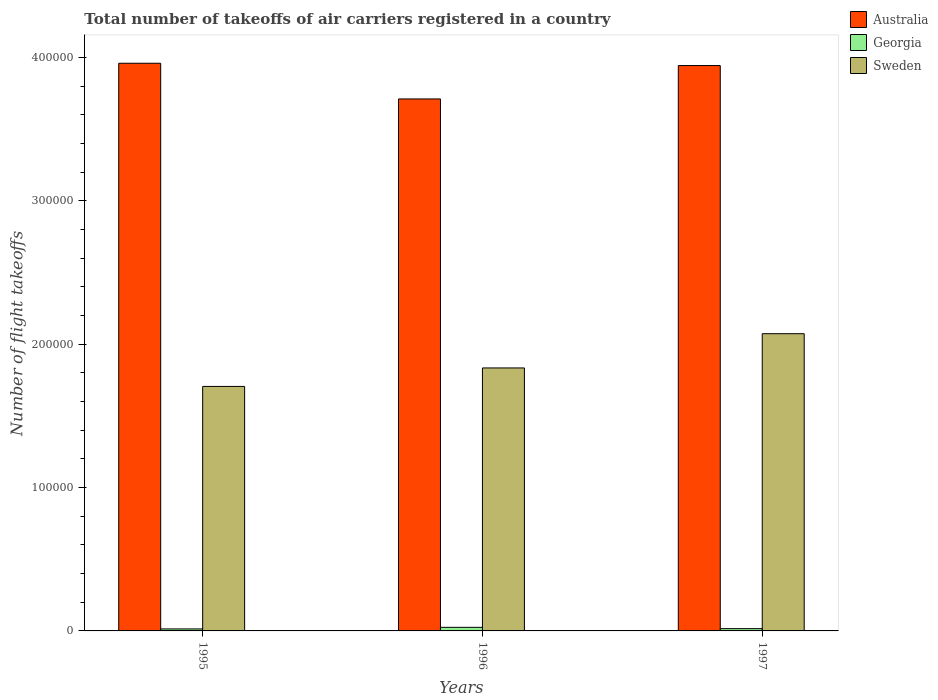How many different coloured bars are there?
Offer a terse response. 3. How many groups of bars are there?
Keep it short and to the point. 3. Are the number of bars per tick equal to the number of legend labels?
Provide a short and direct response. Yes. In how many cases, is the number of bars for a given year not equal to the number of legend labels?
Keep it short and to the point. 0. What is the total number of flight takeoffs in Sweden in 1997?
Provide a succinct answer. 2.07e+05. Across all years, what is the maximum total number of flight takeoffs in Australia?
Offer a very short reply. 3.96e+05. Across all years, what is the minimum total number of flight takeoffs in Australia?
Provide a succinct answer. 3.71e+05. In which year was the total number of flight takeoffs in Georgia maximum?
Offer a very short reply. 1996. In which year was the total number of flight takeoffs in Georgia minimum?
Make the answer very short. 1995. What is the total total number of flight takeoffs in Georgia in the graph?
Provide a short and direct response. 5500. What is the difference between the total number of flight takeoffs in Australia in 1995 and that in 1997?
Your response must be concise. 1600. What is the difference between the total number of flight takeoffs in Australia in 1996 and the total number of flight takeoffs in Sweden in 1995?
Provide a succinct answer. 2.01e+05. What is the average total number of flight takeoffs in Sweden per year?
Your answer should be compact. 1.87e+05. In the year 1997, what is the difference between the total number of flight takeoffs in Sweden and total number of flight takeoffs in Georgia?
Ensure brevity in your answer.  2.06e+05. What is the ratio of the total number of flight takeoffs in Georgia in 1995 to that in 1996?
Give a very brief answer. 0.56. What is the difference between the highest and the second highest total number of flight takeoffs in Sweden?
Provide a short and direct response. 2.39e+04. What is the difference between the highest and the lowest total number of flight takeoffs in Sweden?
Offer a terse response. 3.68e+04. Is the sum of the total number of flight takeoffs in Sweden in 1995 and 1996 greater than the maximum total number of flight takeoffs in Australia across all years?
Make the answer very short. No. What does the 2nd bar from the left in 1996 represents?
Ensure brevity in your answer.  Georgia. What does the 3rd bar from the right in 1996 represents?
Provide a succinct answer. Australia. Are all the bars in the graph horizontal?
Provide a short and direct response. No. How many years are there in the graph?
Offer a very short reply. 3. Are the values on the major ticks of Y-axis written in scientific E-notation?
Your response must be concise. No. Does the graph contain any zero values?
Ensure brevity in your answer.  No. Does the graph contain grids?
Give a very brief answer. No. Where does the legend appear in the graph?
Make the answer very short. Top right. What is the title of the graph?
Your answer should be very brief. Total number of takeoffs of air carriers registered in a country. Does "Kenya" appear as one of the legend labels in the graph?
Offer a terse response. No. What is the label or title of the X-axis?
Your answer should be very brief. Years. What is the label or title of the Y-axis?
Ensure brevity in your answer.  Number of flight takeoffs. What is the Number of flight takeoffs of Australia in 1995?
Keep it short and to the point. 3.96e+05. What is the Number of flight takeoffs of Georgia in 1995?
Keep it short and to the point. 1400. What is the Number of flight takeoffs of Sweden in 1995?
Offer a very short reply. 1.71e+05. What is the Number of flight takeoffs in Australia in 1996?
Give a very brief answer. 3.71e+05. What is the Number of flight takeoffs of Georgia in 1996?
Keep it short and to the point. 2500. What is the Number of flight takeoffs of Sweden in 1996?
Keep it short and to the point. 1.84e+05. What is the Number of flight takeoffs of Australia in 1997?
Your answer should be compact. 3.94e+05. What is the Number of flight takeoffs of Georgia in 1997?
Offer a very short reply. 1600. What is the Number of flight takeoffs of Sweden in 1997?
Your answer should be very brief. 2.07e+05. Across all years, what is the maximum Number of flight takeoffs in Australia?
Provide a short and direct response. 3.96e+05. Across all years, what is the maximum Number of flight takeoffs in Georgia?
Keep it short and to the point. 2500. Across all years, what is the maximum Number of flight takeoffs of Sweden?
Provide a succinct answer. 2.07e+05. Across all years, what is the minimum Number of flight takeoffs in Australia?
Keep it short and to the point. 3.71e+05. Across all years, what is the minimum Number of flight takeoffs of Georgia?
Offer a very short reply. 1400. Across all years, what is the minimum Number of flight takeoffs in Sweden?
Provide a succinct answer. 1.71e+05. What is the total Number of flight takeoffs in Australia in the graph?
Ensure brevity in your answer.  1.16e+06. What is the total Number of flight takeoffs of Georgia in the graph?
Offer a very short reply. 5500. What is the total Number of flight takeoffs in Sweden in the graph?
Provide a succinct answer. 5.62e+05. What is the difference between the Number of flight takeoffs of Australia in 1995 and that in 1996?
Provide a succinct answer. 2.49e+04. What is the difference between the Number of flight takeoffs in Georgia in 1995 and that in 1996?
Your answer should be compact. -1100. What is the difference between the Number of flight takeoffs in Sweden in 1995 and that in 1996?
Offer a very short reply. -1.29e+04. What is the difference between the Number of flight takeoffs in Australia in 1995 and that in 1997?
Your answer should be very brief. 1600. What is the difference between the Number of flight takeoffs in Georgia in 1995 and that in 1997?
Your answer should be very brief. -200. What is the difference between the Number of flight takeoffs of Sweden in 1995 and that in 1997?
Your answer should be very brief. -3.68e+04. What is the difference between the Number of flight takeoffs of Australia in 1996 and that in 1997?
Give a very brief answer. -2.33e+04. What is the difference between the Number of flight takeoffs of Georgia in 1996 and that in 1997?
Your answer should be compact. 900. What is the difference between the Number of flight takeoffs in Sweden in 1996 and that in 1997?
Your answer should be very brief. -2.39e+04. What is the difference between the Number of flight takeoffs in Australia in 1995 and the Number of flight takeoffs in Georgia in 1996?
Offer a very short reply. 3.94e+05. What is the difference between the Number of flight takeoffs of Australia in 1995 and the Number of flight takeoffs of Sweden in 1996?
Provide a succinct answer. 2.13e+05. What is the difference between the Number of flight takeoffs of Georgia in 1995 and the Number of flight takeoffs of Sweden in 1996?
Make the answer very short. -1.82e+05. What is the difference between the Number of flight takeoffs in Australia in 1995 and the Number of flight takeoffs in Georgia in 1997?
Your answer should be compact. 3.94e+05. What is the difference between the Number of flight takeoffs of Australia in 1995 and the Number of flight takeoffs of Sweden in 1997?
Your answer should be very brief. 1.89e+05. What is the difference between the Number of flight takeoffs of Georgia in 1995 and the Number of flight takeoffs of Sweden in 1997?
Your answer should be very brief. -2.06e+05. What is the difference between the Number of flight takeoffs of Australia in 1996 and the Number of flight takeoffs of Georgia in 1997?
Offer a terse response. 3.70e+05. What is the difference between the Number of flight takeoffs in Australia in 1996 and the Number of flight takeoffs in Sweden in 1997?
Keep it short and to the point. 1.64e+05. What is the difference between the Number of flight takeoffs of Georgia in 1996 and the Number of flight takeoffs of Sweden in 1997?
Make the answer very short. -2.05e+05. What is the average Number of flight takeoffs in Australia per year?
Make the answer very short. 3.87e+05. What is the average Number of flight takeoffs of Georgia per year?
Your answer should be very brief. 1833.33. What is the average Number of flight takeoffs in Sweden per year?
Provide a short and direct response. 1.87e+05. In the year 1995, what is the difference between the Number of flight takeoffs in Australia and Number of flight takeoffs in Georgia?
Your response must be concise. 3.95e+05. In the year 1995, what is the difference between the Number of flight takeoffs of Australia and Number of flight takeoffs of Sweden?
Offer a terse response. 2.26e+05. In the year 1995, what is the difference between the Number of flight takeoffs in Georgia and Number of flight takeoffs in Sweden?
Offer a terse response. -1.69e+05. In the year 1996, what is the difference between the Number of flight takeoffs in Australia and Number of flight takeoffs in Georgia?
Ensure brevity in your answer.  3.69e+05. In the year 1996, what is the difference between the Number of flight takeoffs in Australia and Number of flight takeoffs in Sweden?
Give a very brief answer. 1.88e+05. In the year 1996, what is the difference between the Number of flight takeoffs of Georgia and Number of flight takeoffs of Sweden?
Ensure brevity in your answer.  -1.81e+05. In the year 1997, what is the difference between the Number of flight takeoffs of Australia and Number of flight takeoffs of Georgia?
Your answer should be compact. 3.93e+05. In the year 1997, what is the difference between the Number of flight takeoffs of Australia and Number of flight takeoffs of Sweden?
Your answer should be very brief. 1.87e+05. In the year 1997, what is the difference between the Number of flight takeoffs of Georgia and Number of flight takeoffs of Sweden?
Your response must be concise. -2.06e+05. What is the ratio of the Number of flight takeoffs of Australia in 1995 to that in 1996?
Your response must be concise. 1.07. What is the ratio of the Number of flight takeoffs in Georgia in 1995 to that in 1996?
Offer a very short reply. 0.56. What is the ratio of the Number of flight takeoffs in Sweden in 1995 to that in 1996?
Ensure brevity in your answer.  0.93. What is the ratio of the Number of flight takeoffs of Sweden in 1995 to that in 1997?
Offer a terse response. 0.82. What is the ratio of the Number of flight takeoffs in Australia in 1996 to that in 1997?
Offer a terse response. 0.94. What is the ratio of the Number of flight takeoffs in Georgia in 1996 to that in 1997?
Offer a terse response. 1.56. What is the ratio of the Number of flight takeoffs of Sweden in 1996 to that in 1997?
Provide a succinct answer. 0.88. What is the difference between the highest and the second highest Number of flight takeoffs in Australia?
Offer a terse response. 1600. What is the difference between the highest and the second highest Number of flight takeoffs in Georgia?
Your answer should be compact. 900. What is the difference between the highest and the second highest Number of flight takeoffs of Sweden?
Give a very brief answer. 2.39e+04. What is the difference between the highest and the lowest Number of flight takeoffs of Australia?
Your answer should be very brief. 2.49e+04. What is the difference between the highest and the lowest Number of flight takeoffs of Georgia?
Provide a short and direct response. 1100. What is the difference between the highest and the lowest Number of flight takeoffs of Sweden?
Your response must be concise. 3.68e+04. 